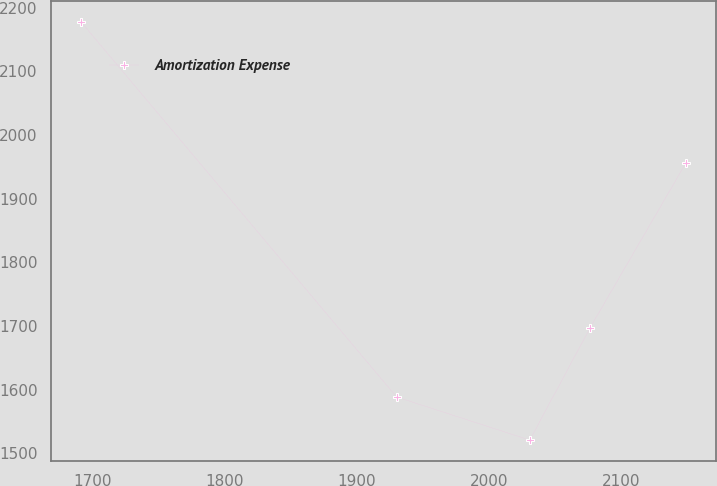<chart> <loc_0><loc_0><loc_500><loc_500><line_chart><ecel><fcel>Amortization Expense<nl><fcel>1691.62<fcel>2177.95<nl><fcel>1930.16<fcel>1588.44<nl><fcel>2030.8<fcel>1520.71<nl><fcel>2076.5<fcel>1697.57<nl><fcel>2148.65<fcel>1955.68<nl></chart> 